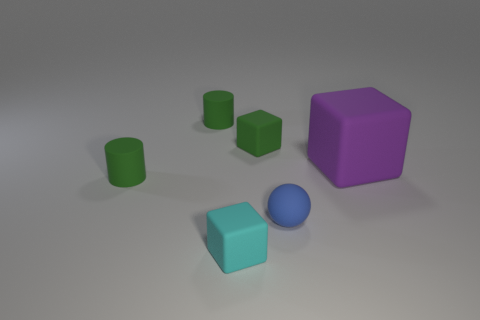What number of other small rubber things are the same shape as the purple object?
Offer a terse response. 2. Are there any tiny green blocks made of the same material as the tiny blue object?
Make the answer very short. Yes. What is the shape of the blue rubber object?
Provide a short and direct response. Sphere. How many cubes are there?
Your answer should be compact. 3. The tiny block behind the block right of the tiny ball is what color?
Provide a succinct answer. Green. There is another cube that is the same size as the cyan block; what is its color?
Ensure brevity in your answer.  Green. Are there any small green matte objects?
Your answer should be compact. Yes. What shape is the tiny green thing that is in front of the small green cube?
Offer a terse response. Cylinder. What number of matte cubes are behind the blue matte sphere and left of the sphere?
Offer a terse response. 1. What number of other objects are the same size as the sphere?
Give a very brief answer. 4. 